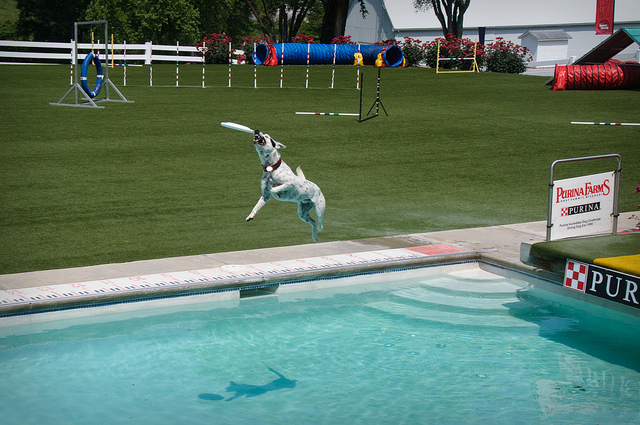Please extract the text content from this image. PUR PURINA FARMS PURINA 